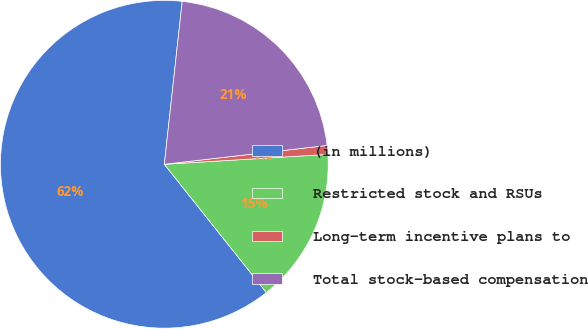<chart> <loc_0><loc_0><loc_500><loc_500><pie_chart><fcel>(in millions)<fcel>Restricted stock and RSUs<fcel>Long-term incentive plans to<fcel>Total stock-based compensation<nl><fcel>62.44%<fcel>15.27%<fcel>0.87%<fcel>21.43%<nl></chart> 